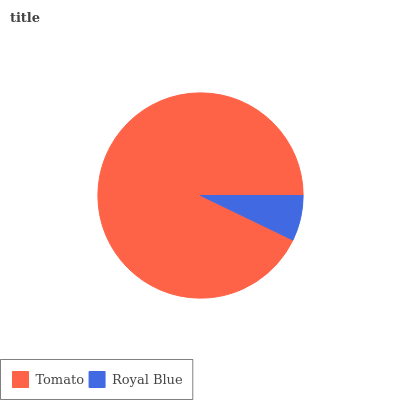Is Royal Blue the minimum?
Answer yes or no. Yes. Is Tomato the maximum?
Answer yes or no. Yes. Is Royal Blue the maximum?
Answer yes or no. No. Is Tomato greater than Royal Blue?
Answer yes or no. Yes. Is Royal Blue less than Tomato?
Answer yes or no. Yes. Is Royal Blue greater than Tomato?
Answer yes or no. No. Is Tomato less than Royal Blue?
Answer yes or no. No. Is Tomato the high median?
Answer yes or no. Yes. Is Royal Blue the low median?
Answer yes or no. Yes. Is Royal Blue the high median?
Answer yes or no. No. Is Tomato the low median?
Answer yes or no. No. 